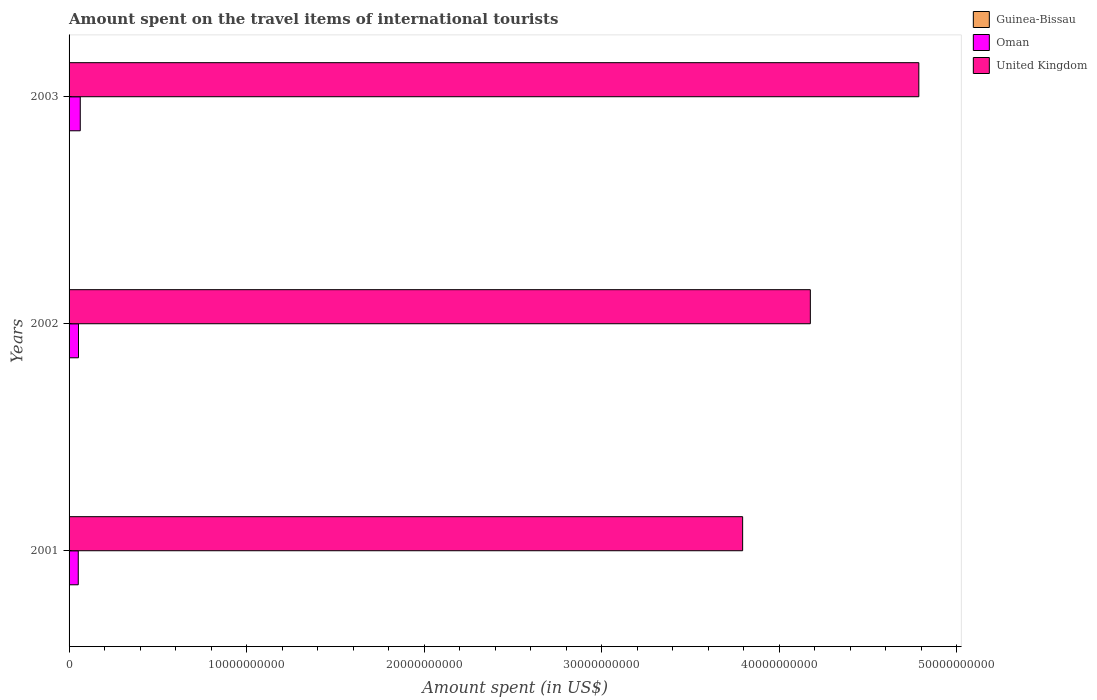How many different coloured bars are there?
Provide a short and direct response. 3. Are the number of bars on each tick of the Y-axis equal?
Your response must be concise. Yes. How many bars are there on the 3rd tick from the bottom?
Your response must be concise. 3. What is the amount spent on the travel items of international tourists in United Kingdom in 2003?
Give a very brief answer. 4.79e+1. Across all years, what is the maximum amount spent on the travel items of international tourists in Oman?
Give a very brief answer. 6.30e+08. Across all years, what is the minimum amount spent on the travel items of international tourists in Oman?
Keep it short and to the point. 5.18e+08. In which year was the amount spent on the travel items of international tourists in Guinea-Bissau minimum?
Offer a terse response. 2001. What is the total amount spent on the travel items of international tourists in Oman in the graph?
Your answer should be compact. 1.68e+09. What is the difference between the amount spent on the travel items of international tourists in Oman in 2002 and that in 2003?
Provide a short and direct response. -1.00e+08. What is the difference between the amount spent on the travel items of international tourists in Oman in 2001 and the amount spent on the travel items of international tourists in United Kingdom in 2003?
Offer a very short reply. -4.73e+1. What is the average amount spent on the travel items of international tourists in United Kingdom per year?
Give a very brief answer. 4.25e+1. In the year 2001, what is the difference between the amount spent on the travel items of international tourists in Oman and amount spent on the travel items of international tourists in United Kingdom?
Keep it short and to the point. -3.74e+1. In how many years, is the amount spent on the travel items of international tourists in Guinea-Bissau greater than 46000000000 US$?
Your answer should be compact. 0. What is the ratio of the amount spent on the travel items of international tourists in Guinea-Bissau in 2002 to that in 2003?
Your answer should be very brief. 0.38. Is the amount spent on the travel items of international tourists in Guinea-Bissau in 2001 less than that in 2002?
Your answer should be compact. Yes. Is the difference between the amount spent on the travel items of international tourists in Oman in 2002 and 2003 greater than the difference between the amount spent on the travel items of international tourists in United Kingdom in 2002 and 2003?
Give a very brief answer. Yes. What is the difference between the highest and the second highest amount spent on the travel items of international tourists in Oman?
Keep it short and to the point. 1.00e+08. What is the difference between the highest and the lowest amount spent on the travel items of international tourists in Guinea-Bissau?
Provide a succinct answer. 1.05e+07. In how many years, is the amount spent on the travel items of international tourists in United Kingdom greater than the average amount spent on the travel items of international tourists in United Kingdom taken over all years?
Offer a terse response. 1. What does the 2nd bar from the top in 2001 represents?
Ensure brevity in your answer.  Oman. What does the 2nd bar from the bottom in 2003 represents?
Your response must be concise. Oman. How many bars are there?
Provide a succinct answer. 9. Are the values on the major ticks of X-axis written in scientific E-notation?
Ensure brevity in your answer.  No. Does the graph contain any zero values?
Provide a succinct answer. No. Does the graph contain grids?
Keep it short and to the point. No. Where does the legend appear in the graph?
Give a very brief answer. Top right. How many legend labels are there?
Your answer should be compact. 3. How are the legend labels stacked?
Your answer should be very brief. Vertical. What is the title of the graph?
Ensure brevity in your answer.  Amount spent on the travel items of international tourists. What is the label or title of the X-axis?
Your answer should be compact. Amount spent (in US$). What is the label or title of the Y-axis?
Offer a terse response. Years. What is the Amount spent (in US$) of Guinea-Bissau in 2001?
Ensure brevity in your answer.  2.80e+06. What is the Amount spent (in US$) of Oman in 2001?
Your answer should be very brief. 5.18e+08. What is the Amount spent (in US$) of United Kingdom in 2001?
Keep it short and to the point. 3.79e+1. What is the Amount spent (in US$) in Guinea-Bissau in 2002?
Ensure brevity in your answer.  5.10e+06. What is the Amount spent (in US$) of Oman in 2002?
Keep it short and to the point. 5.30e+08. What is the Amount spent (in US$) in United Kingdom in 2002?
Keep it short and to the point. 4.17e+1. What is the Amount spent (in US$) of Guinea-Bissau in 2003?
Provide a short and direct response. 1.33e+07. What is the Amount spent (in US$) of Oman in 2003?
Offer a very short reply. 6.30e+08. What is the Amount spent (in US$) in United Kingdom in 2003?
Your response must be concise. 4.79e+1. Across all years, what is the maximum Amount spent (in US$) of Guinea-Bissau?
Provide a succinct answer. 1.33e+07. Across all years, what is the maximum Amount spent (in US$) in Oman?
Keep it short and to the point. 6.30e+08. Across all years, what is the maximum Amount spent (in US$) in United Kingdom?
Make the answer very short. 4.79e+1. Across all years, what is the minimum Amount spent (in US$) in Guinea-Bissau?
Offer a terse response. 2.80e+06. Across all years, what is the minimum Amount spent (in US$) in Oman?
Your response must be concise. 5.18e+08. Across all years, what is the minimum Amount spent (in US$) of United Kingdom?
Keep it short and to the point. 3.79e+1. What is the total Amount spent (in US$) in Guinea-Bissau in the graph?
Ensure brevity in your answer.  2.12e+07. What is the total Amount spent (in US$) in Oman in the graph?
Your response must be concise. 1.68e+09. What is the total Amount spent (in US$) in United Kingdom in the graph?
Your answer should be compact. 1.28e+11. What is the difference between the Amount spent (in US$) of Guinea-Bissau in 2001 and that in 2002?
Offer a very short reply. -2.30e+06. What is the difference between the Amount spent (in US$) in Oman in 2001 and that in 2002?
Offer a very short reply. -1.20e+07. What is the difference between the Amount spent (in US$) in United Kingdom in 2001 and that in 2002?
Your answer should be compact. -3.81e+09. What is the difference between the Amount spent (in US$) in Guinea-Bissau in 2001 and that in 2003?
Make the answer very short. -1.05e+07. What is the difference between the Amount spent (in US$) in Oman in 2001 and that in 2003?
Make the answer very short. -1.12e+08. What is the difference between the Amount spent (in US$) in United Kingdom in 2001 and that in 2003?
Keep it short and to the point. -9.92e+09. What is the difference between the Amount spent (in US$) of Guinea-Bissau in 2002 and that in 2003?
Give a very brief answer. -8.20e+06. What is the difference between the Amount spent (in US$) of Oman in 2002 and that in 2003?
Offer a very short reply. -1.00e+08. What is the difference between the Amount spent (in US$) in United Kingdom in 2002 and that in 2003?
Give a very brief answer. -6.11e+09. What is the difference between the Amount spent (in US$) of Guinea-Bissau in 2001 and the Amount spent (in US$) of Oman in 2002?
Provide a short and direct response. -5.27e+08. What is the difference between the Amount spent (in US$) in Guinea-Bissau in 2001 and the Amount spent (in US$) in United Kingdom in 2002?
Offer a terse response. -4.17e+1. What is the difference between the Amount spent (in US$) of Oman in 2001 and the Amount spent (in US$) of United Kingdom in 2002?
Your response must be concise. -4.12e+1. What is the difference between the Amount spent (in US$) in Guinea-Bissau in 2001 and the Amount spent (in US$) in Oman in 2003?
Provide a succinct answer. -6.27e+08. What is the difference between the Amount spent (in US$) of Guinea-Bissau in 2001 and the Amount spent (in US$) of United Kingdom in 2003?
Provide a short and direct response. -4.79e+1. What is the difference between the Amount spent (in US$) of Oman in 2001 and the Amount spent (in US$) of United Kingdom in 2003?
Your answer should be compact. -4.73e+1. What is the difference between the Amount spent (in US$) of Guinea-Bissau in 2002 and the Amount spent (in US$) of Oman in 2003?
Keep it short and to the point. -6.25e+08. What is the difference between the Amount spent (in US$) in Guinea-Bissau in 2002 and the Amount spent (in US$) in United Kingdom in 2003?
Keep it short and to the point. -4.78e+1. What is the difference between the Amount spent (in US$) in Oman in 2002 and the Amount spent (in US$) in United Kingdom in 2003?
Ensure brevity in your answer.  -4.73e+1. What is the average Amount spent (in US$) of Guinea-Bissau per year?
Provide a succinct answer. 7.07e+06. What is the average Amount spent (in US$) in Oman per year?
Provide a short and direct response. 5.59e+08. What is the average Amount spent (in US$) in United Kingdom per year?
Provide a short and direct response. 4.25e+1. In the year 2001, what is the difference between the Amount spent (in US$) in Guinea-Bissau and Amount spent (in US$) in Oman?
Your response must be concise. -5.15e+08. In the year 2001, what is the difference between the Amount spent (in US$) in Guinea-Bissau and Amount spent (in US$) in United Kingdom?
Offer a very short reply. -3.79e+1. In the year 2001, what is the difference between the Amount spent (in US$) of Oman and Amount spent (in US$) of United Kingdom?
Offer a terse response. -3.74e+1. In the year 2002, what is the difference between the Amount spent (in US$) in Guinea-Bissau and Amount spent (in US$) in Oman?
Your response must be concise. -5.25e+08. In the year 2002, what is the difference between the Amount spent (in US$) of Guinea-Bissau and Amount spent (in US$) of United Kingdom?
Keep it short and to the point. -4.17e+1. In the year 2002, what is the difference between the Amount spent (in US$) in Oman and Amount spent (in US$) in United Kingdom?
Your response must be concise. -4.12e+1. In the year 2003, what is the difference between the Amount spent (in US$) of Guinea-Bissau and Amount spent (in US$) of Oman?
Your answer should be compact. -6.17e+08. In the year 2003, what is the difference between the Amount spent (in US$) of Guinea-Bissau and Amount spent (in US$) of United Kingdom?
Ensure brevity in your answer.  -4.78e+1. In the year 2003, what is the difference between the Amount spent (in US$) in Oman and Amount spent (in US$) in United Kingdom?
Keep it short and to the point. -4.72e+1. What is the ratio of the Amount spent (in US$) of Guinea-Bissau in 2001 to that in 2002?
Your answer should be compact. 0.55. What is the ratio of the Amount spent (in US$) in Oman in 2001 to that in 2002?
Provide a short and direct response. 0.98. What is the ratio of the Amount spent (in US$) in United Kingdom in 2001 to that in 2002?
Make the answer very short. 0.91. What is the ratio of the Amount spent (in US$) of Guinea-Bissau in 2001 to that in 2003?
Your response must be concise. 0.21. What is the ratio of the Amount spent (in US$) in Oman in 2001 to that in 2003?
Your answer should be very brief. 0.82. What is the ratio of the Amount spent (in US$) in United Kingdom in 2001 to that in 2003?
Provide a short and direct response. 0.79. What is the ratio of the Amount spent (in US$) in Guinea-Bissau in 2002 to that in 2003?
Your answer should be compact. 0.38. What is the ratio of the Amount spent (in US$) in Oman in 2002 to that in 2003?
Provide a short and direct response. 0.84. What is the ratio of the Amount spent (in US$) of United Kingdom in 2002 to that in 2003?
Ensure brevity in your answer.  0.87. What is the difference between the highest and the second highest Amount spent (in US$) of Guinea-Bissau?
Your answer should be compact. 8.20e+06. What is the difference between the highest and the second highest Amount spent (in US$) of United Kingdom?
Give a very brief answer. 6.11e+09. What is the difference between the highest and the lowest Amount spent (in US$) in Guinea-Bissau?
Provide a short and direct response. 1.05e+07. What is the difference between the highest and the lowest Amount spent (in US$) of Oman?
Offer a terse response. 1.12e+08. What is the difference between the highest and the lowest Amount spent (in US$) of United Kingdom?
Your answer should be compact. 9.92e+09. 